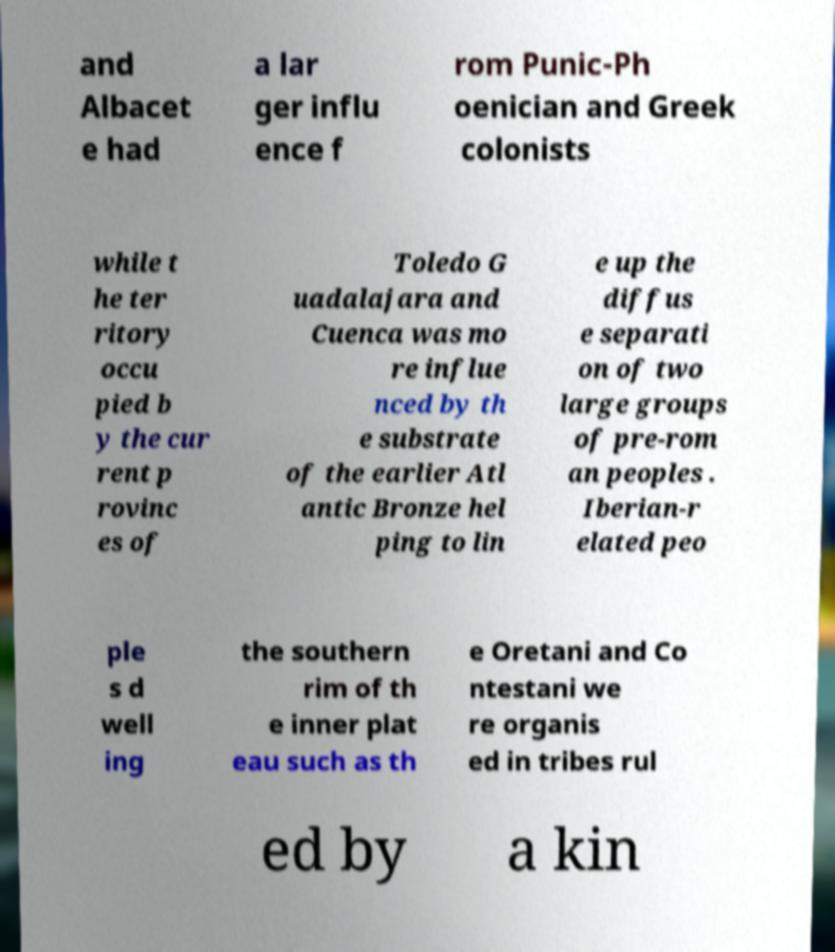Can you read and provide the text displayed in the image?This photo seems to have some interesting text. Can you extract and type it out for me? and Albacet e had a lar ger influ ence f rom Punic-Ph oenician and Greek colonists while t he ter ritory occu pied b y the cur rent p rovinc es of Toledo G uadalajara and Cuenca was mo re influe nced by th e substrate of the earlier Atl antic Bronze hel ping to lin e up the diffus e separati on of two large groups of pre-rom an peoples . Iberian-r elated peo ple s d well ing the southern rim of th e inner plat eau such as th e Oretani and Co ntestani we re organis ed in tribes rul ed by a kin 